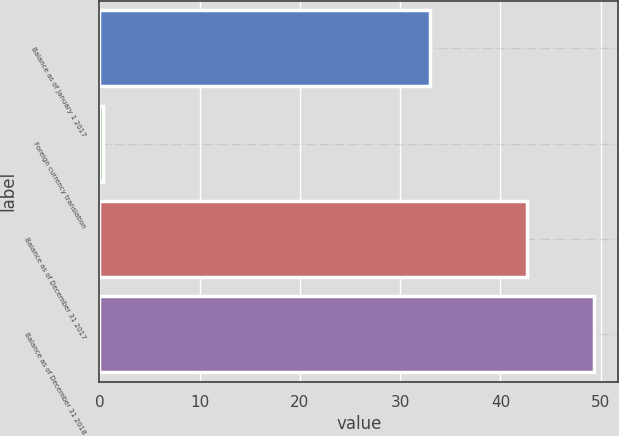Convert chart. <chart><loc_0><loc_0><loc_500><loc_500><bar_chart><fcel>Balance as of January 1 2017<fcel>Foreign currency translation<fcel>Balance as of December 31 2017<fcel>Balance as of December 31 2018<nl><fcel>32.99<fcel>0.4<fcel>42.6<fcel>49.3<nl></chart> 